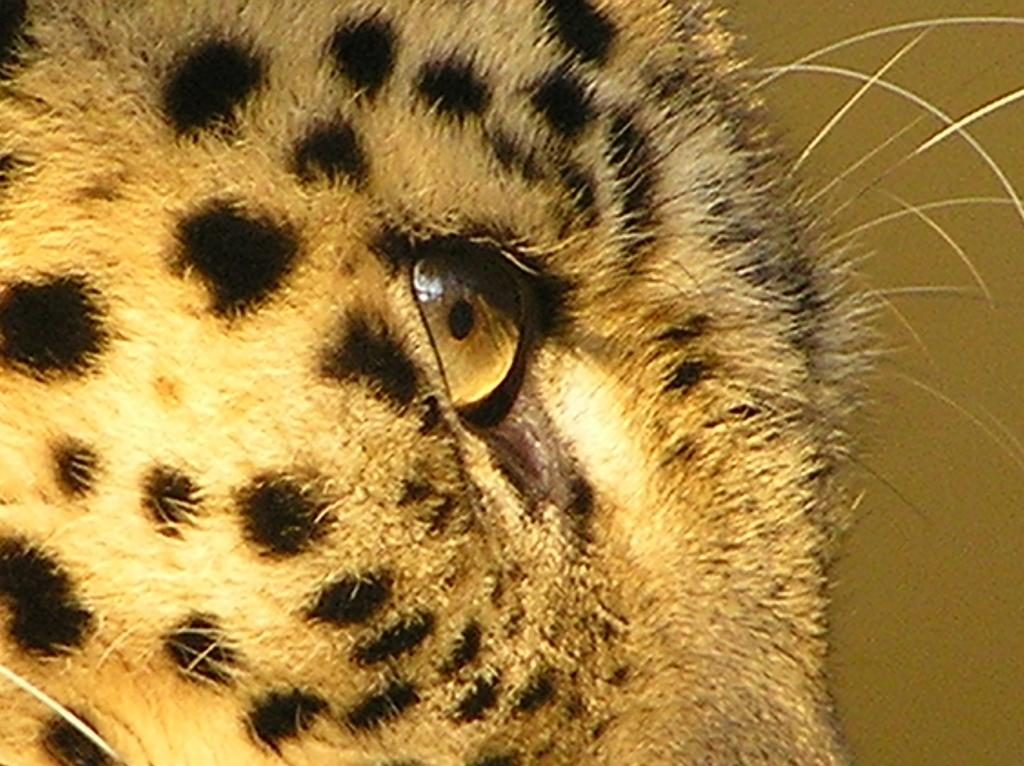What is the main subject of the image? The main subject of the image is a tiger's eye. Can you describe the tiger's eye in the image? The tiger's eye is in the center of the image. What type of leather is used to make the things in the image? There are no things or leather present in the image; it only features a tiger's eye. Can you solve the riddle that is depicted in the image? There is no riddle present in the image; it only features a tiger's eye. 